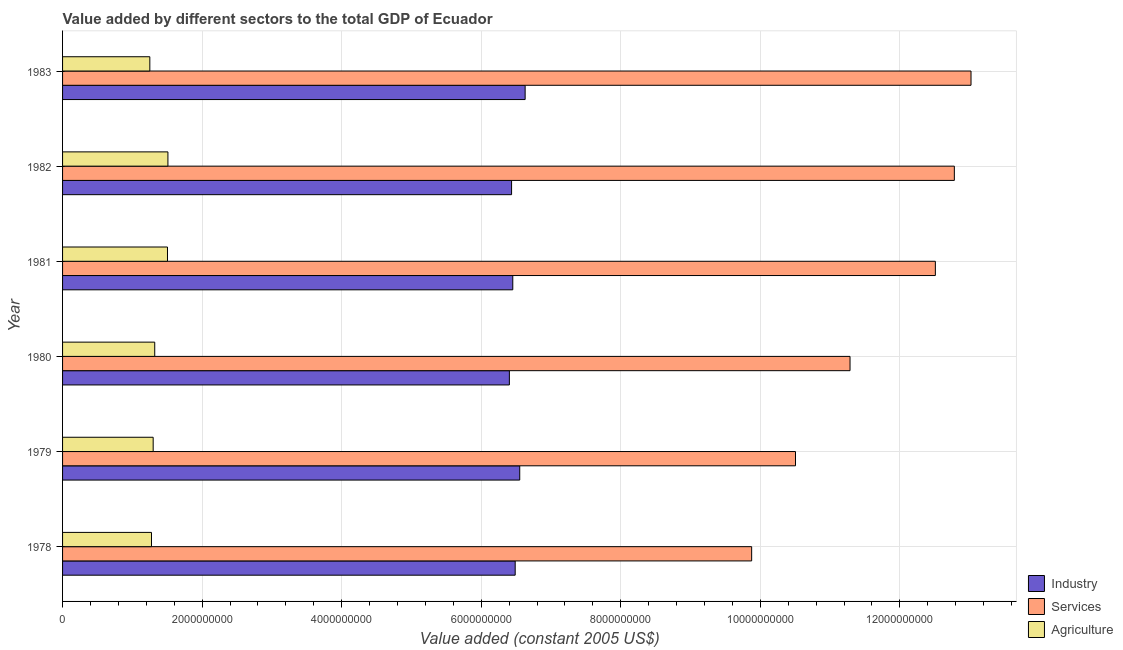How many groups of bars are there?
Keep it short and to the point. 6. How many bars are there on the 6th tick from the top?
Make the answer very short. 3. What is the label of the 5th group of bars from the top?
Offer a terse response. 1979. What is the value added by industrial sector in 1979?
Provide a short and direct response. 6.55e+09. Across all years, what is the maximum value added by agricultural sector?
Give a very brief answer. 1.51e+09. Across all years, what is the minimum value added by agricultural sector?
Make the answer very short. 1.25e+09. What is the total value added by industrial sector in the graph?
Give a very brief answer. 3.90e+1. What is the difference between the value added by services in 1978 and that in 1982?
Ensure brevity in your answer.  -2.90e+09. What is the difference between the value added by industrial sector in 1982 and the value added by services in 1981?
Provide a short and direct response. -6.07e+09. What is the average value added by agricultural sector per year?
Give a very brief answer. 1.36e+09. In the year 1980, what is the difference between the value added by services and value added by industrial sector?
Provide a succinct answer. 4.88e+09. What is the ratio of the value added by services in 1980 to that in 1981?
Ensure brevity in your answer.  0.9. Is the value added by industrial sector in 1978 less than that in 1982?
Ensure brevity in your answer.  No. What is the difference between the highest and the second highest value added by services?
Offer a terse response. 2.39e+08. What is the difference between the highest and the lowest value added by industrial sector?
Offer a very short reply. 2.26e+08. What does the 2nd bar from the top in 1981 represents?
Make the answer very short. Services. What does the 1st bar from the bottom in 1981 represents?
Your response must be concise. Industry. How many bars are there?
Give a very brief answer. 18. Are all the bars in the graph horizontal?
Offer a very short reply. Yes. What is the difference between two consecutive major ticks on the X-axis?
Your response must be concise. 2.00e+09. Are the values on the major ticks of X-axis written in scientific E-notation?
Give a very brief answer. No. Does the graph contain any zero values?
Keep it short and to the point. No. How many legend labels are there?
Offer a very short reply. 3. What is the title of the graph?
Offer a terse response. Value added by different sectors to the total GDP of Ecuador. What is the label or title of the X-axis?
Provide a short and direct response. Value added (constant 2005 US$). What is the label or title of the Y-axis?
Provide a succinct answer. Year. What is the Value added (constant 2005 US$) of Industry in 1978?
Your response must be concise. 6.49e+09. What is the Value added (constant 2005 US$) of Services in 1978?
Keep it short and to the point. 9.88e+09. What is the Value added (constant 2005 US$) in Agriculture in 1978?
Offer a terse response. 1.27e+09. What is the Value added (constant 2005 US$) of Industry in 1979?
Give a very brief answer. 6.55e+09. What is the Value added (constant 2005 US$) of Services in 1979?
Give a very brief answer. 1.05e+1. What is the Value added (constant 2005 US$) of Agriculture in 1979?
Give a very brief answer. 1.30e+09. What is the Value added (constant 2005 US$) of Industry in 1980?
Provide a short and direct response. 6.40e+09. What is the Value added (constant 2005 US$) in Services in 1980?
Your response must be concise. 1.13e+1. What is the Value added (constant 2005 US$) in Agriculture in 1980?
Provide a succinct answer. 1.32e+09. What is the Value added (constant 2005 US$) in Industry in 1981?
Offer a very short reply. 6.45e+09. What is the Value added (constant 2005 US$) of Services in 1981?
Provide a short and direct response. 1.25e+1. What is the Value added (constant 2005 US$) of Agriculture in 1981?
Offer a very short reply. 1.50e+09. What is the Value added (constant 2005 US$) in Industry in 1982?
Keep it short and to the point. 6.44e+09. What is the Value added (constant 2005 US$) in Services in 1982?
Give a very brief answer. 1.28e+1. What is the Value added (constant 2005 US$) in Agriculture in 1982?
Keep it short and to the point. 1.51e+09. What is the Value added (constant 2005 US$) in Industry in 1983?
Your response must be concise. 6.63e+09. What is the Value added (constant 2005 US$) in Services in 1983?
Offer a terse response. 1.30e+1. What is the Value added (constant 2005 US$) of Agriculture in 1983?
Provide a succinct answer. 1.25e+09. Across all years, what is the maximum Value added (constant 2005 US$) in Industry?
Provide a succinct answer. 6.63e+09. Across all years, what is the maximum Value added (constant 2005 US$) of Services?
Offer a terse response. 1.30e+1. Across all years, what is the maximum Value added (constant 2005 US$) in Agriculture?
Offer a very short reply. 1.51e+09. Across all years, what is the minimum Value added (constant 2005 US$) in Industry?
Provide a short and direct response. 6.40e+09. Across all years, what is the minimum Value added (constant 2005 US$) in Services?
Keep it short and to the point. 9.88e+09. Across all years, what is the minimum Value added (constant 2005 US$) in Agriculture?
Make the answer very short. 1.25e+09. What is the total Value added (constant 2005 US$) in Industry in the graph?
Offer a terse response. 3.90e+1. What is the total Value added (constant 2005 US$) in Services in the graph?
Provide a short and direct response. 7.00e+1. What is the total Value added (constant 2005 US$) of Agriculture in the graph?
Offer a terse response. 8.16e+09. What is the difference between the Value added (constant 2005 US$) in Industry in 1978 and that in 1979?
Ensure brevity in your answer.  -6.53e+07. What is the difference between the Value added (constant 2005 US$) of Services in 1978 and that in 1979?
Your answer should be very brief. -6.28e+08. What is the difference between the Value added (constant 2005 US$) in Agriculture in 1978 and that in 1979?
Keep it short and to the point. -2.42e+07. What is the difference between the Value added (constant 2005 US$) of Industry in 1978 and that in 1980?
Keep it short and to the point. 8.34e+07. What is the difference between the Value added (constant 2005 US$) of Services in 1978 and that in 1980?
Offer a terse response. -1.41e+09. What is the difference between the Value added (constant 2005 US$) in Agriculture in 1978 and that in 1980?
Make the answer very short. -4.65e+07. What is the difference between the Value added (constant 2005 US$) of Industry in 1978 and that in 1981?
Ensure brevity in your answer.  3.44e+07. What is the difference between the Value added (constant 2005 US$) of Services in 1978 and that in 1981?
Offer a terse response. -2.63e+09. What is the difference between the Value added (constant 2005 US$) of Agriculture in 1978 and that in 1981?
Ensure brevity in your answer.  -2.29e+08. What is the difference between the Value added (constant 2005 US$) of Industry in 1978 and that in 1982?
Offer a terse response. 5.18e+07. What is the difference between the Value added (constant 2005 US$) of Services in 1978 and that in 1982?
Ensure brevity in your answer.  -2.90e+09. What is the difference between the Value added (constant 2005 US$) in Agriculture in 1978 and that in 1982?
Offer a very short reply. -2.36e+08. What is the difference between the Value added (constant 2005 US$) in Industry in 1978 and that in 1983?
Your response must be concise. -1.43e+08. What is the difference between the Value added (constant 2005 US$) of Services in 1978 and that in 1983?
Make the answer very short. -3.14e+09. What is the difference between the Value added (constant 2005 US$) of Agriculture in 1978 and that in 1983?
Keep it short and to the point. 2.38e+07. What is the difference between the Value added (constant 2005 US$) of Industry in 1979 and that in 1980?
Your answer should be compact. 1.49e+08. What is the difference between the Value added (constant 2005 US$) in Services in 1979 and that in 1980?
Offer a very short reply. -7.82e+08. What is the difference between the Value added (constant 2005 US$) of Agriculture in 1979 and that in 1980?
Offer a terse response. -2.23e+07. What is the difference between the Value added (constant 2005 US$) in Industry in 1979 and that in 1981?
Provide a succinct answer. 9.97e+07. What is the difference between the Value added (constant 2005 US$) of Services in 1979 and that in 1981?
Offer a very short reply. -2.00e+09. What is the difference between the Value added (constant 2005 US$) of Agriculture in 1979 and that in 1981?
Give a very brief answer. -2.05e+08. What is the difference between the Value added (constant 2005 US$) of Industry in 1979 and that in 1982?
Make the answer very short. 1.17e+08. What is the difference between the Value added (constant 2005 US$) of Services in 1979 and that in 1982?
Keep it short and to the point. -2.28e+09. What is the difference between the Value added (constant 2005 US$) of Agriculture in 1979 and that in 1982?
Provide a succinct answer. -2.11e+08. What is the difference between the Value added (constant 2005 US$) of Industry in 1979 and that in 1983?
Give a very brief answer. -7.74e+07. What is the difference between the Value added (constant 2005 US$) in Services in 1979 and that in 1983?
Provide a succinct answer. -2.52e+09. What is the difference between the Value added (constant 2005 US$) in Agriculture in 1979 and that in 1983?
Ensure brevity in your answer.  4.80e+07. What is the difference between the Value added (constant 2005 US$) of Industry in 1980 and that in 1981?
Your response must be concise. -4.90e+07. What is the difference between the Value added (constant 2005 US$) in Services in 1980 and that in 1981?
Give a very brief answer. -1.22e+09. What is the difference between the Value added (constant 2005 US$) of Agriculture in 1980 and that in 1981?
Provide a succinct answer. -1.83e+08. What is the difference between the Value added (constant 2005 US$) of Industry in 1980 and that in 1982?
Provide a succinct answer. -3.16e+07. What is the difference between the Value added (constant 2005 US$) of Services in 1980 and that in 1982?
Give a very brief answer. -1.50e+09. What is the difference between the Value added (constant 2005 US$) of Agriculture in 1980 and that in 1982?
Your response must be concise. -1.89e+08. What is the difference between the Value added (constant 2005 US$) of Industry in 1980 and that in 1983?
Make the answer very short. -2.26e+08. What is the difference between the Value added (constant 2005 US$) of Services in 1980 and that in 1983?
Ensure brevity in your answer.  -1.73e+09. What is the difference between the Value added (constant 2005 US$) of Agriculture in 1980 and that in 1983?
Make the answer very short. 7.03e+07. What is the difference between the Value added (constant 2005 US$) in Industry in 1981 and that in 1982?
Give a very brief answer. 1.74e+07. What is the difference between the Value added (constant 2005 US$) in Services in 1981 and that in 1982?
Your answer should be very brief. -2.72e+08. What is the difference between the Value added (constant 2005 US$) in Agriculture in 1981 and that in 1982?
Keep it short and to the point. -6.32e+06. What is the difference between the Value added (constant 2005 US$) of Industry in 1981 and that in 1983?
Make the answer very short. -1.77e+08. What is the difference between the Value added (constant 2005 US$) of Services in 1981 and that in 1983?
Provide a short and direct response. -5.11e+08. What is the difference between the Value added (constant 2005 US$) in Agriculture in 1981 and that in 1983?
Make the answer very short. 2.53e+08. What is the difference between the Value added (constant 2005 US$) in Industry in 1982 and that in 1983?
Your response must be concise. -1.94e+08. What is the difference between the Value added (constant 2005 US$) of Services in 1982 and that in 1983?
Provide a short and direct response. -2.39e+08. What is the difference between the Value added (constant 2005 US$) in Agriculture in 1982 and that in 1983?
Provide a succinct answer. 2.59e+08. What is the difference between the Value added (constant 2005 US$) of Industry in 1978 and the Value added (constant 2005 US$) of Services in 1979?
Your answer should be very brief. -4.02e+09. What is the difference between the Value added (constant 2005 US$) in Industry in 1978 and the Value added (constant 2005 US$) in Agriculture in 1979?
Give a very brief answer. 5.19e+09. What is the difference between the Value added (constant 2005 US$) of Services in 1978 and the Value added (constant 2005 US$) of Agriculture in 1979?
Your response must be concise. 8.58e+09. What is the difference between the Value added (constant 2005 US$) of Industry in 1978 and the Value added (constant 2005 US$) of Services in 1980?
Give a very brief answer. -4.80e+09. What is the difference between the Value added (constant 2005 US$) of Industry in 1978 and the Value added (constant 2005 US$) of Agriculture in 1980?
Offer a very short reply. 5.17e+09. What is the difference between the Value added (constant 2005 US$) in Services in 1978 and the Value added (constant 2005 US$) in Agriculture in 1980?
Provide a succinct answer. 8.56e+09. What is the difference between the Value added (constant 2005 US$) in Industry in 1978 and the Value added (constant 2005 US$) in Services in 1981?
Offer a terse response. -6.02e+09. What is the difference between the Value added (constant 2005 US$) in Industry in 1978 and the Value added (constant 2005 US$) in Agriculture in 1981?
Make the answer very short. 4.98e+09. What is the difference between the Value added (constant 2005 US$) of Services in 1978 and the Value added (constant 2005 US$) of Agriculture in 1981?
Your answer should be compact. 8.37e+09. What is the difference between the Value added (constant 2005 US$) of Industry in 1978 and the Value added (constant 2005 US$) of Services in 1982?
Give a very brief answer. -6.29e+09. What is the difference between the Value added (constant 2005 US$) in Industry in 1978 and the Value added (constant 2005 US$) in Agriculture in 1982?
Provide a succinct answer. 4.98e+09. What is the difference between the Value added (constant 2005 US$) of Services in 1978 and the Value added (constant 2005 US$) of Agriculture in 1982?
Offer a terse response. 8.37e+09. What is the difference between the Value added (constant 2005 US$) of Industry in 1978 and the Value added (constant 2005 US$) of Services in 1983?
Ensure brevity in your answer.  -6.53e+09. What is the difference between the Value added (constant 2005 US$) of Industry in 1978 and the Value added (constant 2005 US$) of Agriculture in 1983?
Make the answer very short. 5.24e+09. What is the difference between the Value added (constant 2005 US$) of Services in 1978 and the Value added (constant 2005 US$) of Agriculture in 1983?
Your answer should be compact. 8.63e+09. What is the difference between the Value added (constant 2005 US$) of Industry in 1979 and the Value added (constant 2005 US$) of Services in 1980?
Make the answer very short. -4.73e+09. What is the difference between the Value added (constant 2005 US$) in Industry in 1979 and the Value added (constant 2005 US$) in Agriculture in 1980?
Offer a terse response. 5.23e+09. What is the difference between the Value added (constant 2005 US$) of Services in 1979 and the Value added (constant 2005 US$) of Agriculture in 1980?
Your response must be concise. 9.18e+09. What is the difference between the Value added (constant 2005 US$) of Industry in 1979 and the Value added (constant 2005 US$) of Services in 1981?
Offer a very short reply. -5.96e+09. What is the difference between the Value added (constant 2005 US$) in Industry in 1979 and the Value added (constant 2005 US$) in Agriculture in 1981?
Your response must be concise. 5.05e+09. What is the difference between the Value added (constant 2005 US$) of Services in 1979 and the Value added (constant 2005 US$) of Agriculture in 1981?
Provide a succinct answer. 9.00e+09. What is the difference between the Value added (constant 2005 US$) of Industry in 1979 and the Value added (constant 2005 US$) of Services in 1982?
Keep it short and to the point. -6.23e+09. What is the difference between the Value added (constant 2005 US$) in Industry in 1979 and the Value added (constant 2005 US$) in Agriculture in 1982?
Keep it short and to the point. 5.04e+09. What is the difference between the Value added (constant 2005 US$) of Services in 1979 and the Value added (constant 2005 US$) of Agriculture in 1982?
Your answer should be very brief. 8.99e+09. What is the difference between the Value added (constant 2005 US$) in Industry in 1979 and the Value added (constant 2005 US$) in Services in 1983?
Keep it short and to the point. -6.47e+09. What is the difference between the Value added (constant 2005 US$) in Industry in 1979 and the Value added (constant 2005 US$) in Agriculture in 1983?
Ensure brevity in your answer.  5.30e+09. What is the difference between the Value added (constant 2005 US$) of Services in 1979 and the Value added (constant 2005 US$) of Agriculture in 1983?
Offer a very short reply. 9.25e+09. What is the difference between the Value added (constant 2005 US$) in Industry in 1980 and the Value added (constant 2005 US$) in Services in 1981?
Provide a short and direct response. -6.11e+09. What is the difference between the Value added (constant 2005 US$) in Industry in 1980 and the Value added (constant 2005 US$) in Agriculture in 1981?
Make the answer very short. 4.90e+09. What is the difference between the Value added (constant 2005 US$) of Services in 1980 and the Value added (constant 2005 US$) of Agriculture in 1981?
Your answer should be very brief. 9.78e+09. What is the difference between the Value added (constant 2005 US$) in Industry in 1980 and the Value added (constant 2005 US$) in Services in 1982?
Your answer should be compact. -6.38e+09. What is the difference between the Value added (constant 2005 US$) in Industry in 1980 and the Value added (constant 2005 US$) in Agriculture in 1982?
Provide a succinct answer. 4.89e+09. What is the difference between the Value added (constant 2005 US$) in Services in 1980 and the Value added (constant 2005 US$) in Agriculture in 1982?
Offer a terse response. 9.78e+09. What is the difference between the Value added (constant 2005 US$) of Industry in 1980 and the Value added (constant 2005 US$) of Services in 1983?
Offer a terse response. -6.62e+09. What is the difference between the Value added (constant 2005 US$) in Industry in 1980 and the Value added (constant 2005 US$) in Agriculture in 1983?
Offer a very short reply. 5.15e+09. What is the difference between the Value added (constant 2005 US$) in Services in 1980 and the Value added (constant 2005 US$) in Agriculture in 1983?
Your response must be concise. 1.00e+1. What is the difference between the Value added (constant 2005 US$) in Industry in 1981 and the Value added (constant 2005 US$) in Services in 1982?
Ensure brevity in your answer.  -6.33e+09. What is the difference between the Value added (constant 2005 US$) in Industry in 1981 and the Value added (constant 2005 US$) in Agriculture in 1982?
Keep it short and to the point. 4.94e+09. What is the difference between the Value added (constant 2005 US$) of Services in 1981 and the Value added (constant 2005 US$) of Agriculture in 1982?
Provide a succinct answer. 1.10e+1. What is the difference between the Value added (constant 2005 US$) of Industry in 1981 and the Value added (constant 2005 US$) of Services in 1983?
Ensure brevity in your answer.  -6.57e+09. What is the difference between the Value added (constant 2005 US$) in Industry in 1981 and the Value added (constant 2005 US$) in Agriculture in 1983?
Keep it short and to the point. 5.20e+09. What is the difference between the Value added (constant 2005 US$) in Services in 1981 and the Value added (constant 2005 US$) in Agriculture in 1983?
Your answer should be compact. 1.13e+1. What is the difference between the Value added (constant 2005 US$) in Industry in 1982 and the Value added (constant 2005 US$) in Services in 1983?
Your response must be concise. -6.58e+09. What is the difference between the Value added (constant 2005 US$) in Industry in 1982 and the Value added (constant 2005 US$) in Agriculture in 1983?
Make the answer very short. 5.18e+09. What is the difference between the Value added (constant 2005 US$) of Services in 1982 and the Value added (constant 2005 US$) of Agriculture in 1983?
Your answer should be compact. 1.15e+1. What is the average Value added (constant 2005 US$) of Industry per year?
Make the answer very short. 6.49e+09. What is the average Value added (constant 2005 US$) in Services per year?
Provide a succinct answer. 1.17e+1. What is the average Value added (constant 2005 US$) of Agriculture per year?
Provide a succinct answer. 1.36e+09. In the year 1978, what is the difference between the Value added (constant 2005 US$) of Industry and Value added (constant 2005 US$) of Services?
Offer a very short reply. -3.39e+09. In the year 1978, what is the difference between the Value added (constant 2005 US$) of Industry and Value added (constant 2005 US$) of Agriculture?
Your answer should be very brief. 5.21e+09. In the year 1978, what is the difference between the Value added (constant 2005 US$) of Services and Value added (constant 2005 US$) of Agriculture?
Keep it short and to the point. 8.60e+09. In the year 1979, what is the difference between the Value added (constant 2005 US$) of Industry and Value added (constant 2005 US$) of Services?
Your answer should be very brief. -3.95e+09. In the year 1979, what is the difference between the Value added (constant 2005 US$) of Industry and Value added (constant 2005 US$) of Agriculture?
Your answer should be very brief. 5.25e+09. In the year 1979, what is the difference between the Value added (constant 2005 US$) of Services and Value added (constant 2005 US$) of Agriculture?
Your answer should be very brief. 9.21e+09. In the year 1980, what is the difference between the Value added (constant 2005 US$) in Industry and Value added (constant 2005 US$) in Services?
Keep it short and to the point. -4.88e+09. In the year 1980, what is the difference between the Value added (constant 2005 US$) in Industry and Value added (constant 2005 US$) in Agriculture?
Ensure brevity in your answer.  5.08e+09. In the year 1980, what is the difference between the Value added (constant 2005 US$) of Services and Value added (constant 2005 US$) of Agriculture?
Offer a terse response. 9.97e+09. In the year 1981, what is the difference between the Value added (constant 2005 US$) in Industry and Value added (constant 2005 US$) in Services?
Your response must be concise. -6.06e+09. In the year 1981, what is the difference between the Value added (constant 2005 US$) of Industry and Value added (constant 2005 US$) of Agriculture?
Provide a succinct answer. 4.95e+09. In the year 1981, what is the difference between the Value added (constant 2005 US$) of Services and Value added (constant 2005 US$) of Agriculture?
Your answer should be very brief. 1.10e+1. In the year 1982, what is the difference between the Value added (constant 2005 US$) in Industry and Value added (constant 2005 US$) in Services?
Make the answer very short. -6.35e+09. In the year 1982, what is the difference between the Value added (constant 2005 US$) of Industry and Value added (constant 2005 US$) of Agriculture?
Give a very brief answer. 4.93e+09. In the year 1982, what is the difference between the Value added (constant 2005 US$) in Services and Value added (constant 2005 US$) in Agriculture?
Make the answer very short. 1.13e+1. In the year 1983, what is the difference between the Value added (constant 2005 US$) in Industry and Value added (constant 2005 US$) in Services?
Keep it short and to the point. -6.39e+09. In the year 1983, what is the difference between the Value added (constant 2005 US$) of Industry and Value added (constant 2005 US$) of Agriculture?
Your answer should be compact. 5.38e+09. In the year 1983, what is the difference between the Value added (constant 2005 US$) of Services and Value added (constant 2005 US$) of Agriculture?
Offer a terse response. 1.18e+1. What is the ratio of the Value added (constant 2005 US$) in Services in 1978 to that in 1979?
Ensure brevity in your answer.  0.94. What is the ratio of the Value added (constant 2005 US$) of Agriculture in 1978 to that in 1979?
Offer a terse response. 0.98. What is the ratio of the Value added (constant 2005 US$) in Services in 1978 to that in 1980?
Your answer should be compact. 0.88. What is the ratio of the Value added (constant 2005 US$) in Agriculture in 1978 to that in 1980?
Keep it short and to the point. 0.96. What is the ratio of the Value added (constant 2005 US$) in Services in 1978 to that in 1981?
Offer a terse response. 0.79. What is the ratio of the Value added (constant 2005 US$) in Agriculture in 1978 to that in 1981?
Offer a terse response. 0.85. What is the ratio of the Value added (constant 2005 US$) in Services in 1978 to that in 1982?
Provide a short and direct response. 0.77. What is the ratio of the Value added (constant 2005 US$) in Agriculture in 1978 to that in 1982?
Your answer should be compact. 0.84. What is the ratio of the Value added (constant 2005 US$) of Industry in 1978 to that in 1983?
Provide a succinct answer. 0.98. What is the ratio of the Value added (constant 2005 US$) in Services in 1978 to that in 1983?
Give a very brief answer. 0.76. What is the ratio of the Value added (constant 2005 US$) of Industry in 1979 to that in 1980?
Your answer should be very brief. 1.02. What is the ratio of the Value added (constant 2005 US$) in Services in 1979 to that in 1980?
Your response must be concise. 0.93. What is the ratio of the Value added (constant 2005 US$) in Agriculture in 1979 to that in 1980?
Your answer should be compact. 0.98. What is the ratio of the Value added (constant 2005 US$) in Industry in 1979 to that in 1981?
Ensure brevity in your answer.  1.02. What is the ratio of the Value added (constant 2005 US$) of Services in 1979 to that in 1981?
Ensure brevity in your answer.  0.84. What is the ratio of the Value added (constant 2005 US$) of Agriculture in 1979 to that in 1981?
Offer a very short reply. 0.86. What is the ratio of the Value added (constant 2005 US$) in Industry in 1979 to that in 1982?
Offer a very short reply. 1.02. What is the ratio of the Value added (constant 2005 US$) of Services in 1979 to that in 1982?
Give a very brief answer. 0.82. What is the ratio of the Value added (constant 2005 US$) of Agriculture in 1979 to that in 1982?
Ensure brevity in your answer.  0.86. What is the ratio of the Value added (constant 2005 US$) of Industry in 1979 to that in 1983?
Provide a succinct answer. 0.99. What is the ratio of the Value added (constant 2005 US$) of Services in 1979 to that in 1983?
Your response must be concise. 0.81. What is the ratio of the Value added (constant 2005 US$) of Agriculture in 1979 to that in 1983?
Offer a terse response. 1.04. What is the ratio of the Value added (constant 2005 US$) of Industry in 1980 to that in 1981?
Make the answer very short. 0.99. What is the ratio of the Value added (constant 2005 US$) of Services in 1980 to that in 1981?
Your response must be concise. 0.9. What is the ratio of the Value added (constant 2005 US$) in Agriculture in 1980 to that in 1981?
Offer a terse response. 0.88. What is the ratio of the Value added (constant 2005 US$) of Industry in 1980 to that in 1982?
Offer a very short reply. 1. What is the ratio of the Value added (constant 2005 US$) of Services in 1980 to that in 1982?
Offer a very short reply. 0.88. What is the ratio of the Value added (constant 2005 US$) in Agriculture in 1980 to that in 1982?
Provide a succinct answer. 0.87. What is the ratio of the Value added (constant 2005 US$) in Industry in 1980 to that in 1983?
Your answer should be very brief. 0.97. What is the ratio of the Value added (constant 2005 US$) in Services in 1980 to that in 1983?
Give a very brief answer. 0.87. What is the ratio of the Value added (constant 2005 US$) of Agriculture in 1980 to that in 1983?
Ensure brevity in your answer.  1.06. What is the ratio of the Value added (constant 2005 US$) in Industry in 1981 to that in 1982?
Provide a succinct answer. 1. What is the ratio of the Value added (constant 2005 US$) in Services in 1981 to that in 1982?
Keep it short and to the point. 0.98. What is the ratio of the Value added (constant 2005 US$) in Industry in 1981 to that in 1983?
Ensure brevity in your answer.  0.97. What is the ratio of the Value added (constant 2005 US$) of Services in 1981 to that in 1983?
Make the answer very short. 0.96. What is the ratio of the Value added (constant 2005 US$) in Agriculture in 1981 to that in 1983?
Offer a very short reply. 1.2. What is the ratio of the Value added (constant 2005 US$) of Industry in 1982 to that in 1983?
Your answer should be compact. 0.97. What is the ratio of the Value added (constant 2005 US$) of Services in 1982 to that in 1983?
Your answer should be very brief. 0.98. What is the ratio of the Value added (constant 2005 US$) of Agriculture in 1982 to that in 1983?
Give a very brief answer. 1.21. What is the difference between the highest and the second highest Value added (constant 2005 US$) in Industry?
Your answer should be very brief. 7.74e+07. What is the difference between the highest and the second highest Value added (constant 2005 US$) in Services?
Make the answer very short. 2.39e+08. What is the difference between the highest and the second highest Value added (constant 2005 US$) of Agriculture?
Ensure brevity in your answer.  6.32e+06. What is the difference between the highest and the lowest Value added (constant 2005 US$) in Industry?
Your answer should be compact. 2.26e+08. What is the difference between the highest and the lowest Value added (constant 2005 US$) in Services?
Make the answer very short. 3.14e+09. What is the difference between the highest and the lowest Value added (constant 2005 US$) in Agriculture?
Offer a very short reply. 2.59e+08. 